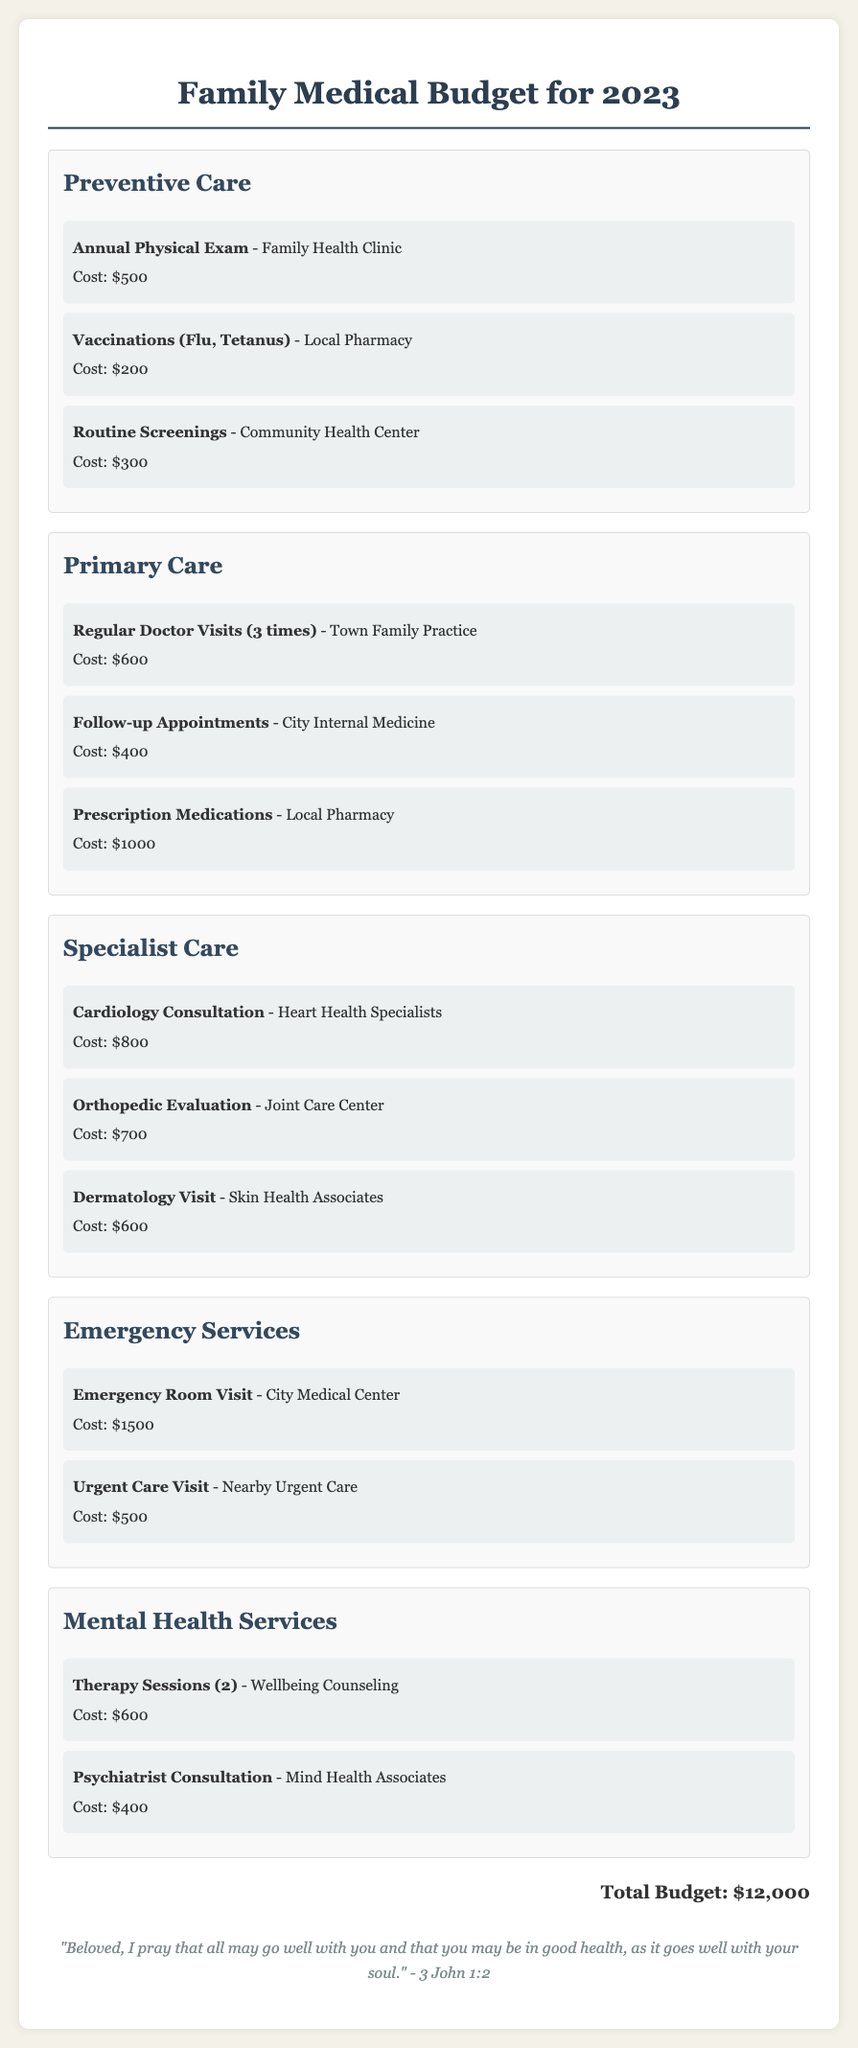What is the total budget for 2023? The total budget is stated at the end of the document summarizing all expenses.
Answer: $12,000 How much does an annual physical exam cost? The cost of the annual physical exam is listed under preventive care services.
Answer: $500 Which provider offers cardiology consultations? The document specifies the provider for cardiology consultations in the specialist care section.
Answer: Heart Health Specialists How many therapy sessions are included in the mental health services? The number of therapy sessions is mentioned in the mental health services category.
Answer: 2 What is the cost of an emergency room visit? The cost of the emergency room visit is specified under emergency services.
Answer: $1500 Which category includes routine screenings? Routine screenings are categorized under preventive care services in the document.
Answer: Preventive Care How many regular doctor visits are budgeted for 2023? The document lists the number of regular doctor visits in the primary care section.
Answer: 3 What is the cost for follow-up appointments? The cost for follow-up appointments is mentioned in the primary care category.
Answer: $400 Which scripture is included at the bottom of the document? The scripture is quoted at the bottom and reflects a theme of health and wellbeing.
Answer: "Beloved, I pray that all may go well with you and that you may be in good health, as it goes well with your soul." - 3 John 1:2 